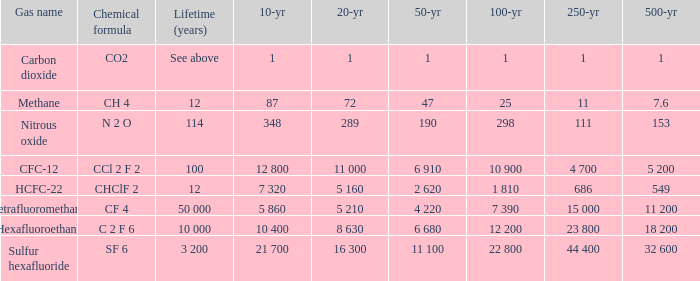What is the 100 year for Carbon Dioxide? 1.0. 